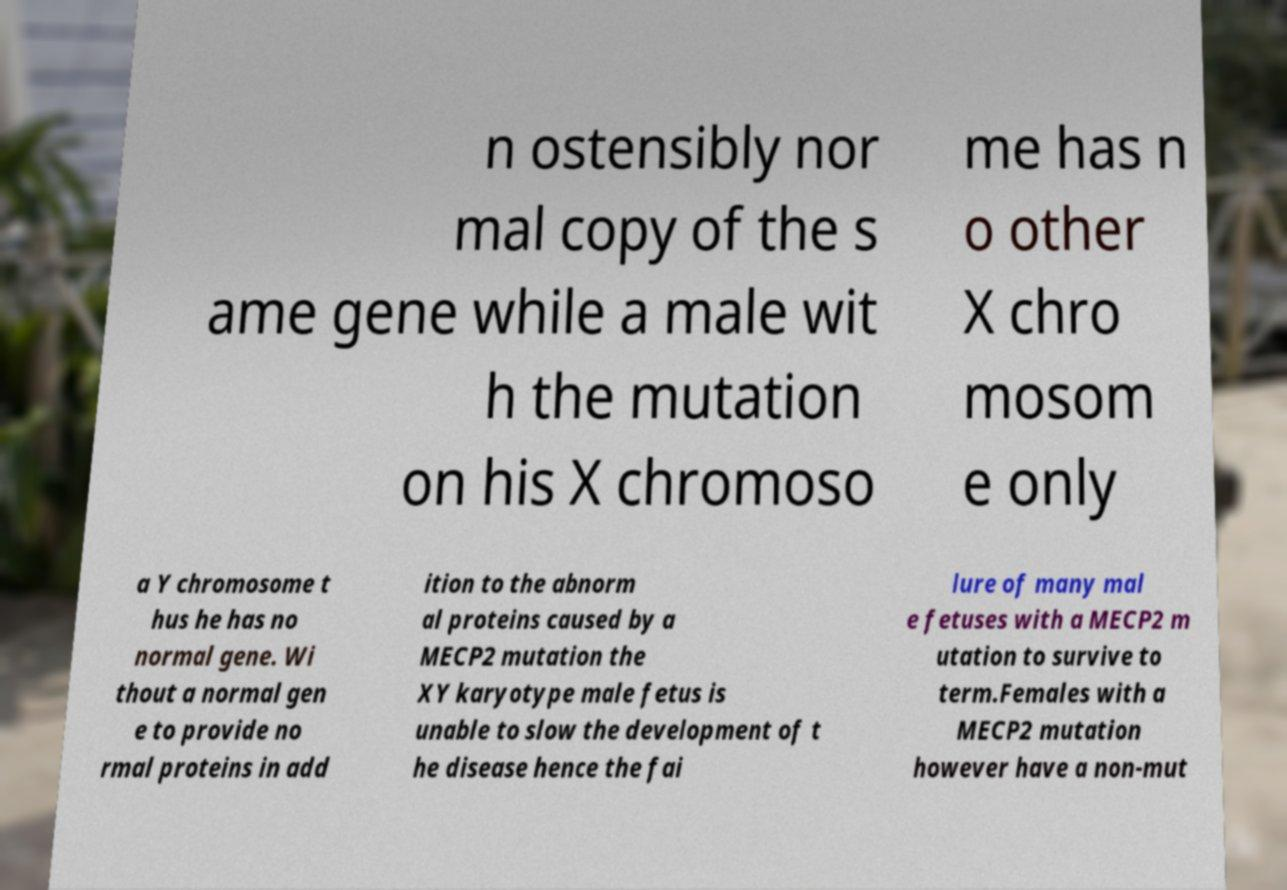Please read and relay the text visible in this image. What does it say? n ostensibly nor mal copy of the s ame gene while a male wit h the mutation on his X chromoso me has n o other X chro mosom e only a Y chromosome t hus he has no normal gene. Wi thout a normal gen e to provide no rmal proteins in add ition to the abnorm al proteins caused by a MECP2 mutation the XY karyotype male fetus is unable to slow the development of t he disease hence the fai lure of many mal e fetuses with a MECP2 m utation to survive to term.Females with a MECP2 mutation however have a non-mut 